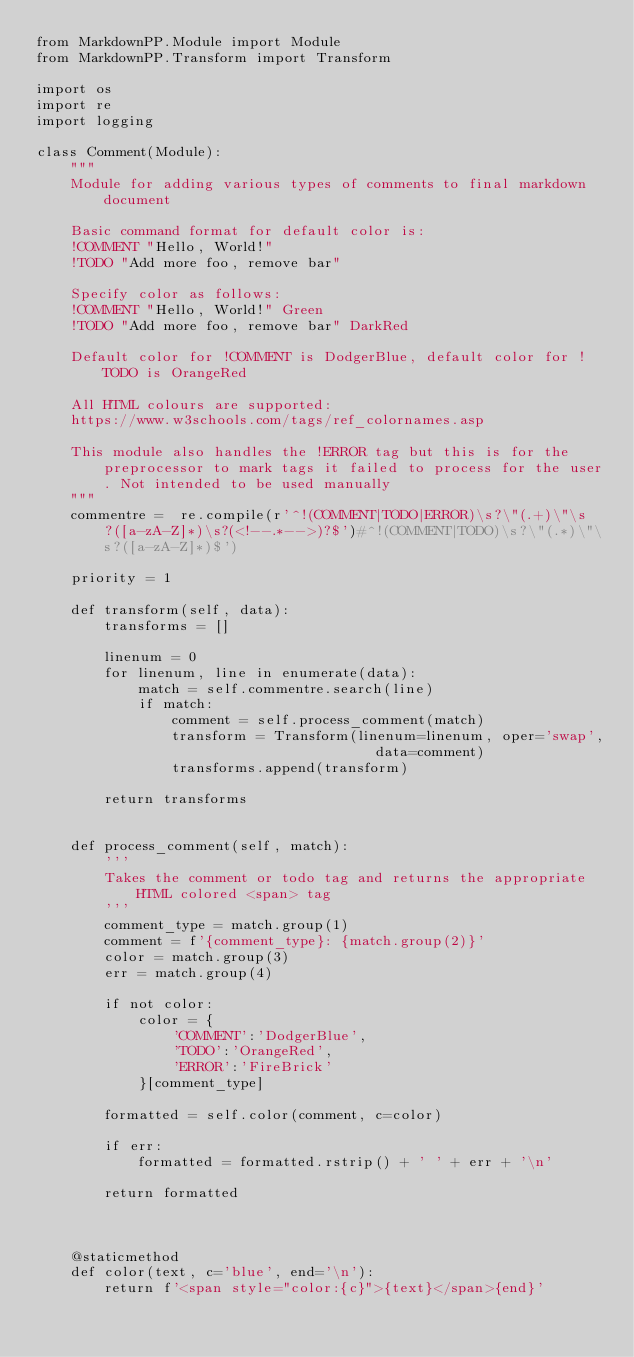<code> <loc_0><loc_0><loc_500><loc_500><_Python_>from MarkdownPP.Module import Module
from MarkdownPP.Transform import Transform

import os
import re
import logging

class Comment(Module):
    """
    Module for adding various types of comments to final markdown document
    
    Basic command format for default color is:
    !COMMENT "Hello, World!" 
    !TODO "Add more foo, remove bar"

    Specify color as follows:
    !COMMENT "Hello, World!" Green
    !TODO "Add more foo, remove bar" DarkRed

    Default color for !COMMENT is DodgerBlue, default color for !TODO is OrangeRed

    All HTML colours are supported:
    https://www.w3schools.com/tags/ref_colornames.asp

    This module also handles the !ERROR tag but this is for the preprocessor to mark tags it failed to process for the user. Not intended to be used manually
    """
    commentre =  re.compile(r'^!(COMMENT|TODO|ERROR)\s?\"(.+)\"\s?([a-zA-Z]*)\s?(<!--.*-->)?$')#^!(COMMENT|TODO)\s?\"(.*)\"\s?([a-zA-Z]*)$')

    priority = 1

    def transform(self, data):
        transforms = []

        linenum = 0
        for linenum, line in enumerate(data):
            match = self.commentre.search(line)
            if match:
                comment = self.process_comment(match)
                transform = Transform(linenum=linenum, oper='swap',
                                        data=comment)
                transforms.append(transform)

        return transforms


    def process_comment(self, match):
        '''
        Takes the comment or todo tag and returns the appropriate HTML colored <span> tag
        '''
        comment_type = match.group(1)
        comment = f'{comment_type}: {match.group(2)}'
        color = match.group(3)
        err = match.group(4)

        if not color:
            color = {
                'COMMENT':'DodgerBlue',
                'TODO':'OrangeRed',
                'ERROR':'FireBrick'
            }[comment_type]

        formatted = self.color(comment, c=color)

        if err:
            formatted = formatted.rstrip() + ' ' + err + '\n'

        return formatted



    @staticmethod
    def color(text, c='blue', end='\n'):
        return f'<span style="color:{c}">{text}</span>{end}'</code> 